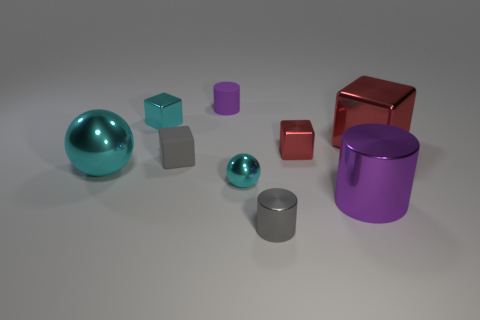There is a metal cylinder that is the same color as the matte cylinder; what is its size?
Your response must be concise. Large. Is the red block right of the large metallic cylinder made of the same material as the small gray cube?
Offer a terse response. No. What is the color of the other tiny thing that is the same shape as the tiny purple rubber object?
Provide a short and direct response. Gray. What is the shape of the gray matte thing?
Ensure brevity in your answer.  Cube. What number of objects are big blue rubber objects or cyan metallic blocks?
Provide a succinct answer. 1. Does the cylinder that is behind the big cyan thing have the same color as the cylinder right of the gray metallic cylinder?
Provide a succinct answer. Yes. What number of other things are the same shape as the big cyan metallic thing?
Make the answer very short. 1. Are there any cyan metallic spheres?
Your answer should be compact. Yes. How many things are either red rubber cylinders or tiny metallic cubes that are behind the tiny red metallic block?
Your response must be concise. 1. There is a gray thing that is behind the purple metallic cylinder; is its size the same as the purple rubber cylinder?
Keep it short and to the point. Yes. 